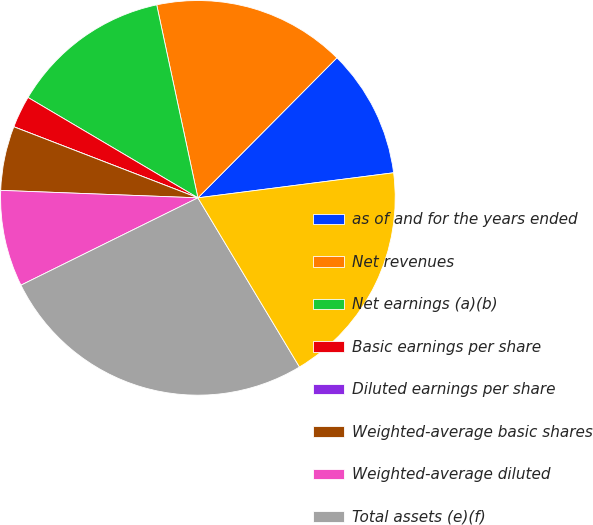Convert chart to OTSL. <chart><loc_0><loc_0><loc_500><loc_500><pie_chart><fcel>as of and for the years ended<fcel>Net revenues<fcel>Net earnings (a)(b)<fcel>Basic earnings per share<fcel>Diluted earnings per share<fcel>Weighted-average basic shares<fcel>Weighted-average diluted<fcel>Total assets (e)(f)<fcel>Long-term debt and lease<nl><fcel>10.53%<fcel>15.79%<fcel>13.16%<fcel>2.63%<fcel>0.0%<fcel>5.26%<fcel>7.9%<fcel>26.31%<fcel>18.42%<nl></chart> 